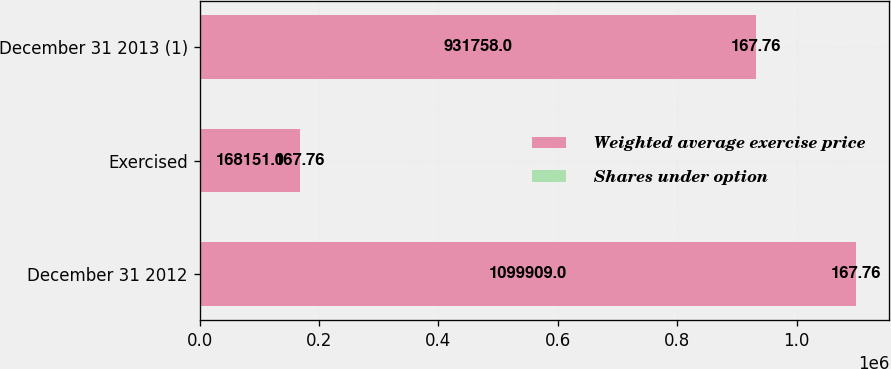<chart> <loc_0><loc_0><loc_500><loc_500><stacked_bar_chart><ecel><fcel>December 31 2012<fcel>Exercised<fcel>December 31 2013 (1)<nl><fcel>Weighted average exercise price<fcel>1.09991e+06<fcel>168151<fcel>931758<nl><fcel>Shares under option<fcel>167.76<fcel>167.76<fcel>167.76<nl></chart> 